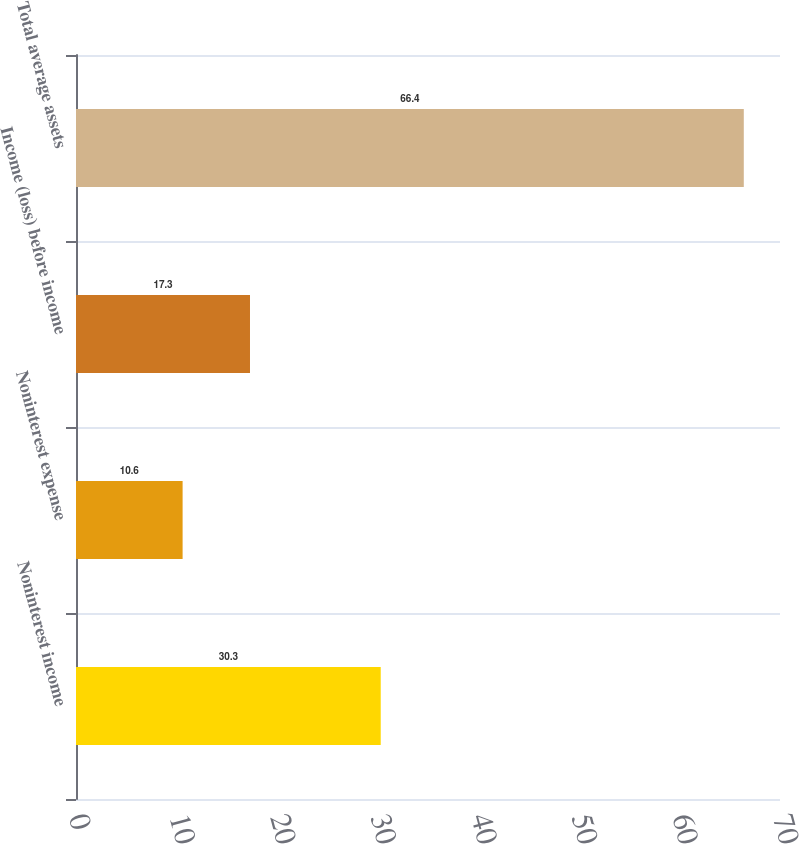<chart> <loc_0><loc_0><loc_500><loc_500><bar_chart><fcel>Noninterest income<fcel>Noninterest expense<fcel>Income (loss) before income<fcel>Total average assets<nl><fcel>30.3<fcel>10.6<fcel>17.3<fcel>66.4<nl></chart> 